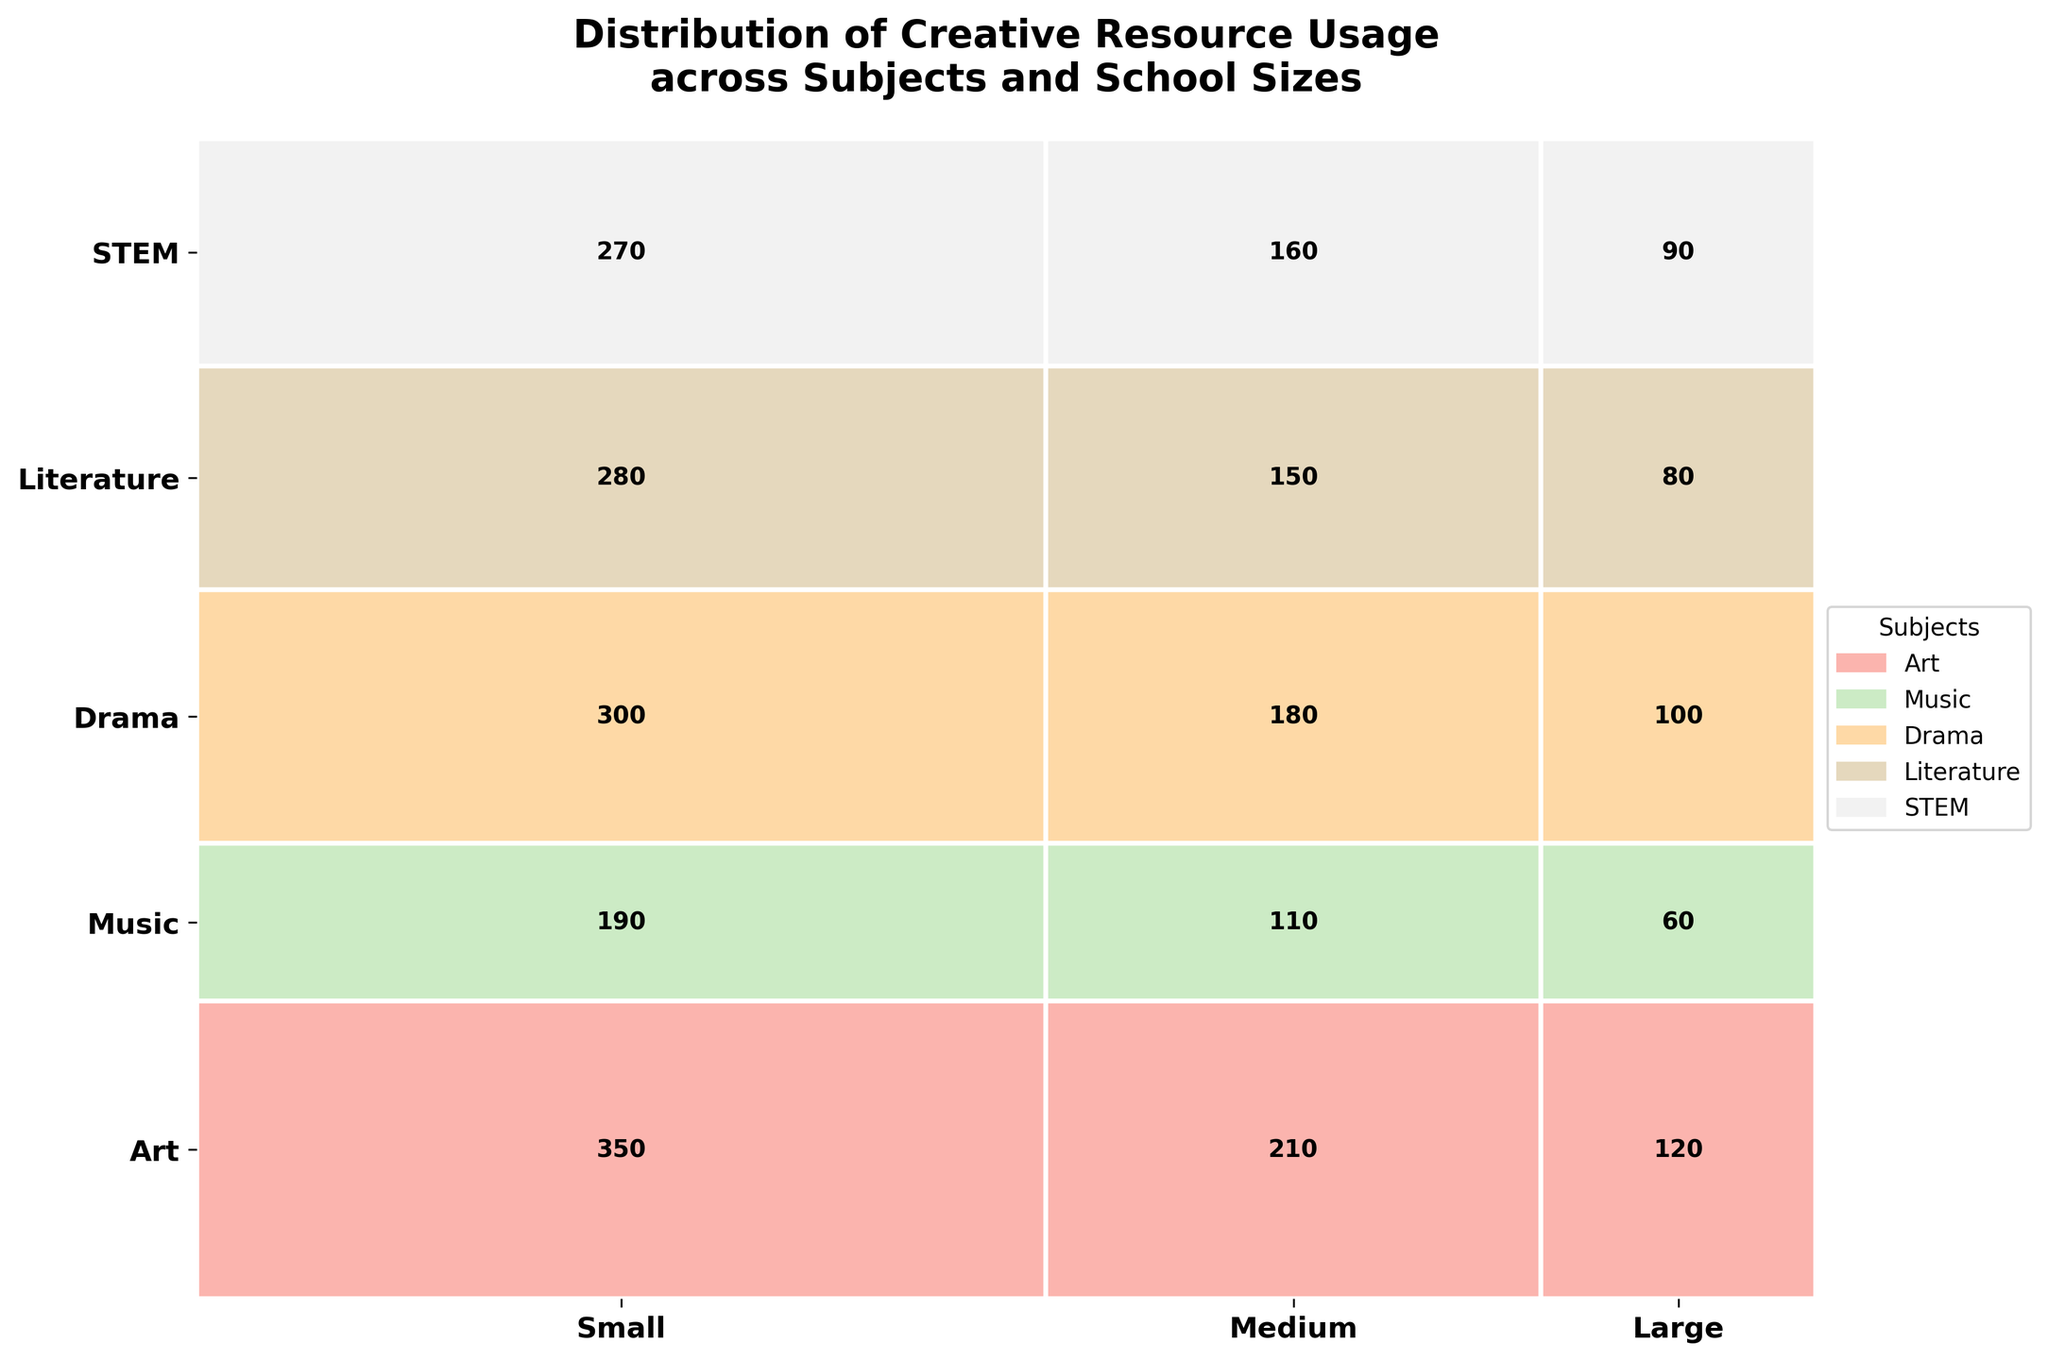What is the total usage count for STEM resources across all school sizes? First, locate the 'STEM' row in the figure. Then, sum the usage counts for Small, Medium, and Large school sizes within that row.
Answer: 520 Which subject has the highest usage count in large schools? Identify the sections allocated to large schools in the figure and compare the usage counts for each subject in these sections. Locate the highest value among these.
Answer: Art How does the usage count for Medium-size schools compare between Music and Drama? For Medium-size schools, find the usage counts for both Music and Drama in the corresponding sections of the figure. Compare these values directly.
Answer: Music: 150, Drama: 110, Music is higher What is the sum of usage counts for small schools across all subjects? Sum the usage counts for Small schools as listed in the sections for Art, Music, Drama, Literature, and STEM.
Answer: 450 Which subject has the smallest overall usage count across all school sizes? Sum up the usage counts for each subject (Art, Music, Drama, Literature, STEM) across all school sizes and identify the subject with the smallest total.
Answer: Drama What is the proportion of usage counts for Literature in medium-size schools compared to the total usage counts for all school sizes? Find the usage count for Literature in medium-size schools. Then, calculate the total usage across all subjects and school sizes. Divide the Literature medium-size usage count by the total usage and express it as a proportion.
Answer: 180 / 2700 = 0.067 (6.7%) Which school size category contributes the most to the Literature usage count? Compare the usage counts of Literature in Small, Medium, and Large school sizes. Determine which school size has the highest value.
Answer: Large How does the relative height of the rectangles compare between Art and Music subjects? Observe the heights assigned to Art and Music sections in the figure and assess their relative differences.
Answer: Art's height is greater than Music's height What is the difference in usage count between the large and small schools for STEM resources? Identify the usage counts of STEM for Large and Small school sizes. Subtract the Small school count from the Large school count.
Answer: 270 - 90 = 180 How many subjects have higher usage counts for large schools compared to medium schools? For each subject, compare the usage counts between Large and Medium school sizes. Count how many subjects have a higher count for Large schools than Medium schools.
Answer: 5 